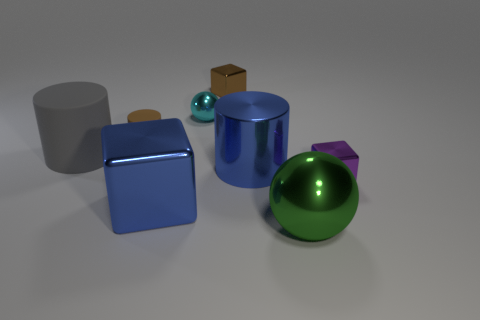Are there any other things that have the same color as the tiny cylinder?
Ensure brevity in your answer.  Yes. There is a large metal object that is the same shape as the small cyan metal object; what color is it?
Your response must be concise. Green. Is the number of small brown rubber objects in front of the cyan metallic sphere greater than the number of red rubber things?
Your answer should be very brief. Yes. What is the color of the shiny cube that is behind the purple metal thing?
Your answer should be compact. Brown. Is the size of the green ball the same as the gray rubber object?
Your answer should be compact. Yes. The blue metallic cylinder has what size?
Provide a short and direct response. Large. What shape is the metal object that is the same color as the shiny cylinder?
Your answer should be compact. Cube. Is the number of gray rubber cylinders greater than the number of small purple spheres?
Keep it short and to the point. Yes. What is the color of the shiny cube that is on the right side of the block that is behind the tiny metallic object on the right side of the green shiny object?
Provide a short and direct response. Purple. Do the small metallic object in front of the tiny cylinder and the large matte object have the same shape?
Your answer should be very brief. No. 